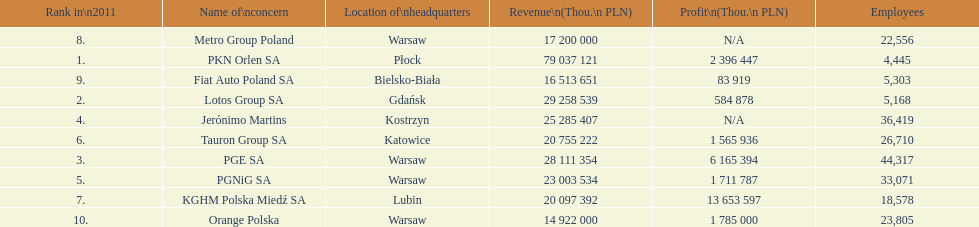What is the difference in employees for rank 1 and rank 3? 39,872 employees. 